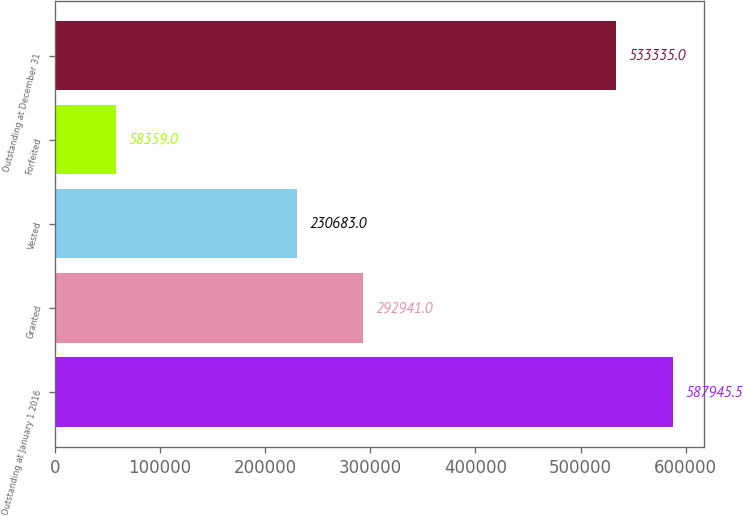Convert chart to OTSL. <chart><loc_0><loc_0><loc_500><loc_500><bar_chart><fcel>Outstanding at January 1 2016<fcel>Granted<fcel>Vested<fcel>Forfeited<fcel>Outstanding at December 31<nl><fcel>587946<fcel>292941<fcel>230683<fcel>58359<fcel>533335<nl></chart> 